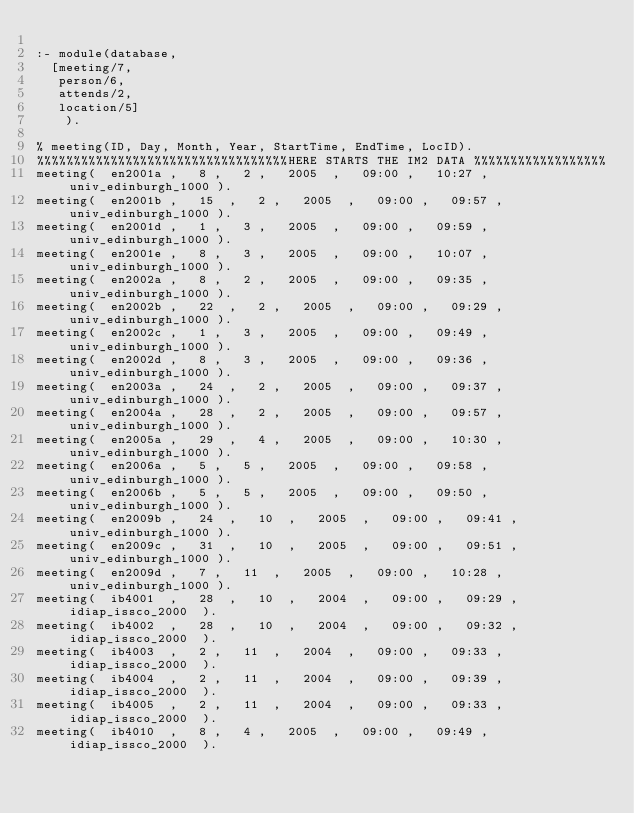Convert code to text. <code><loc_0><loc_0><loc_500><loc_500><_Perl_>
:- module(database,
	[meeting/7,
	 person/6,
	 attends/2,
	 location/5]
    ).

% meeting(ID, Day, Month, Year, StartTime, EndTime, LocID).
%%%%%%%%%%%%%%%%%%%%%%%%%%%%%%%%%%HERE STARTS THE IM2 DATA %%%%%%%%%%%%%%%%%%
meeting(	en2001a	, 	8	, 	2	, 	2005	, 	09:00	, 	10:27	, 	univ_edinburgh_1000	). 
meeting(	en2001b	, 	15	, 	2	, 	2005	, 	09:00	, 	09:57	, 	univ_edinburgh_1000	). 
meeting(	en2001d	, 	1	, 	3	, 	2005	, 	09:00	, 	09:59	, 	univ_edinburgh_1000	). 
meeting(	en2001e	, 	8	, 	3	, 	2005	, 	09:00	, 	10:07	, 	univ_edinburgh_1000	). 
meeting(	en2002a	, 	8	, 	2	, 	2005	, 	09:00	, 	09:35	, 	univ_edinburgh_1000	). 
meeting(	en2002b	, 	22	, 	2	, 	2005	, 	09:00	, 	09:29	, 	univ_edinburgh_1000	). 
meeting(	en2002c	, 	1	, 	3	, 	2005	, 	09:00	, 	09:49	, 	univ_edinburgh_1000	). 
meeting(	en2002d	, 	8	, 	3	, 	2005	, 	09:00	, 	09:36	, 	univ_edinburgh_1000	). 
meeting(	en2003a	, 	24	, 	2	, 	2005	, 	09:00	, 	09:37	, 	univ_edinburgh_1000	). 
meeting(	en2004a	, 	28	, 	2	, 	2005	, 	09:00	, 	09:57	, 	univ_edinburgh_1000	). 
meeting(	en2005a	, 	29	, 	4	, 	2005	, 	09:00	, 	10:30	, 	univ_edinburgh_1000	). 
meeting(	en2006a	, 	5	, 	5	, 	2005	, 	09:00	, 	09:58	, 	univ_edinburgh_1000	). 
meeting(	en2006b	, 	5	, 	5	, 	2005	, 	09:00	, 	09:50	, 	univ_edinburgh_1000	). 
meeting(	en2009b	, 	24	, 	10	, 	2005	, 	09:00	, 	09:41	, 	univ_edinburgh_1000	). 
meeting(	en2009c	, 	31	, 	10	, 	2005	, 	09:00	, 	09:51	, 	univ_edinburgh_1000	). 
meeting(	en2009d	, 	7	, 	11	, 	2005	, 	09:00	, 	10:28	, 	univ_edinburgh_1000	). 
meeting(	ib4001	, 	28	, 	10	, 	2004	, 	09:00	, 	09:29	, 	idiap_issco_2000	). 
meeting(	ib4002	, 	28	, 	10	, 	2004	, 	09:00	, 	09:32	, 	idiap_issco_2000	). 
meeting(	ib4003	, 	2	, 	11	, 	2004	, 	09:00	, 	09:33	, 	idiap_issco_2000	). 
meeting(	ib4004	, 	2	, 	11	, 	2004	, 	09:00	, 	09:39	, 	idiap_issco_2000	). 
meeting(	ib4005	, 	2	, 	11	, 	2004	, 	09:00	, 	09:33	, 	idiap_issco_2000	). 
meeting(	ib4010	, 	8	, 	4	, 	2005	, 	09:00	, 	09:49	, 	idiap_issco_2000	). </code> 